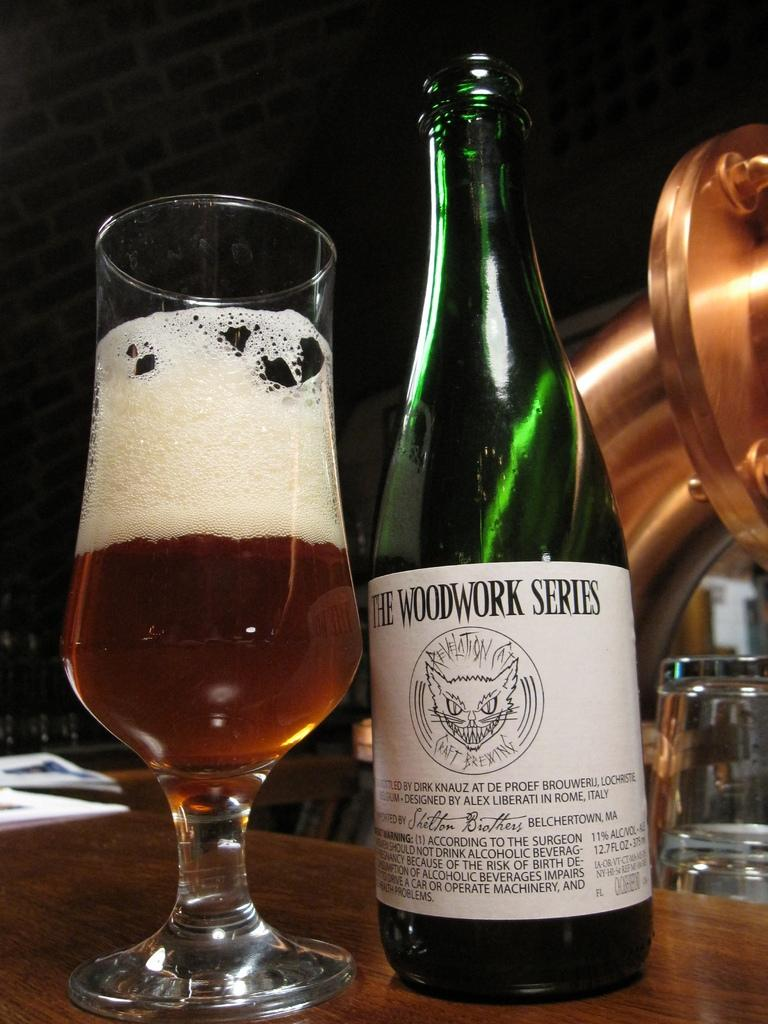<image>
Relay a brief, clear account of the picture shown. the word woodwork that is on a wine bottle 